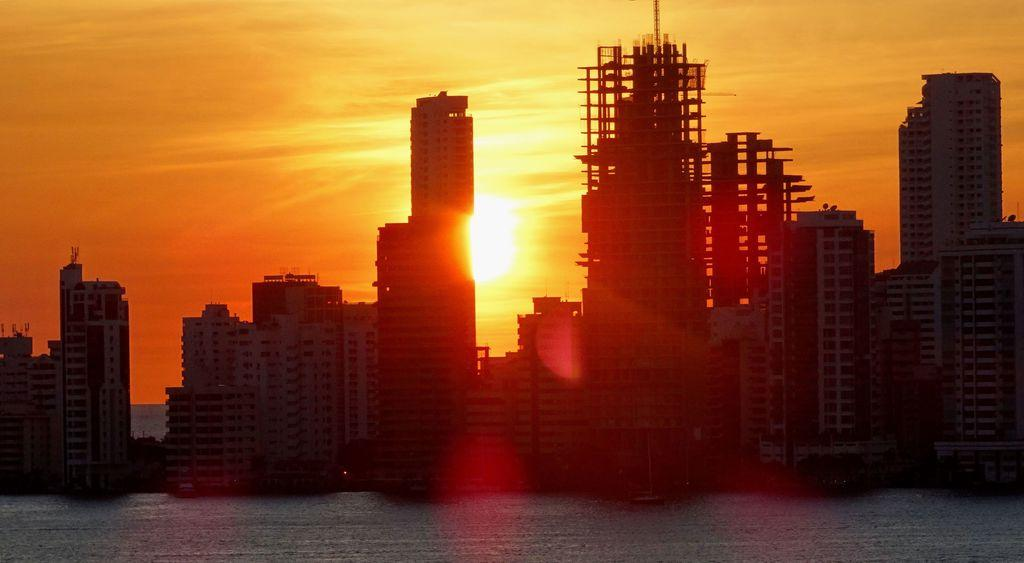What type of natural feature is present in the image? There is a sea in the image. What structures are located in front of the sea? There are tall buildings in front of the sea. What can be seen in the sky behind the buildings? There is a beautiful sunrise visible behind the buildings. What type of quartz can be seen in the image? There is no quartz present in the image. What type of cream is being used to paint the buildings in the image? There is no indication of any painting or cream being used on the buildings in the image. 